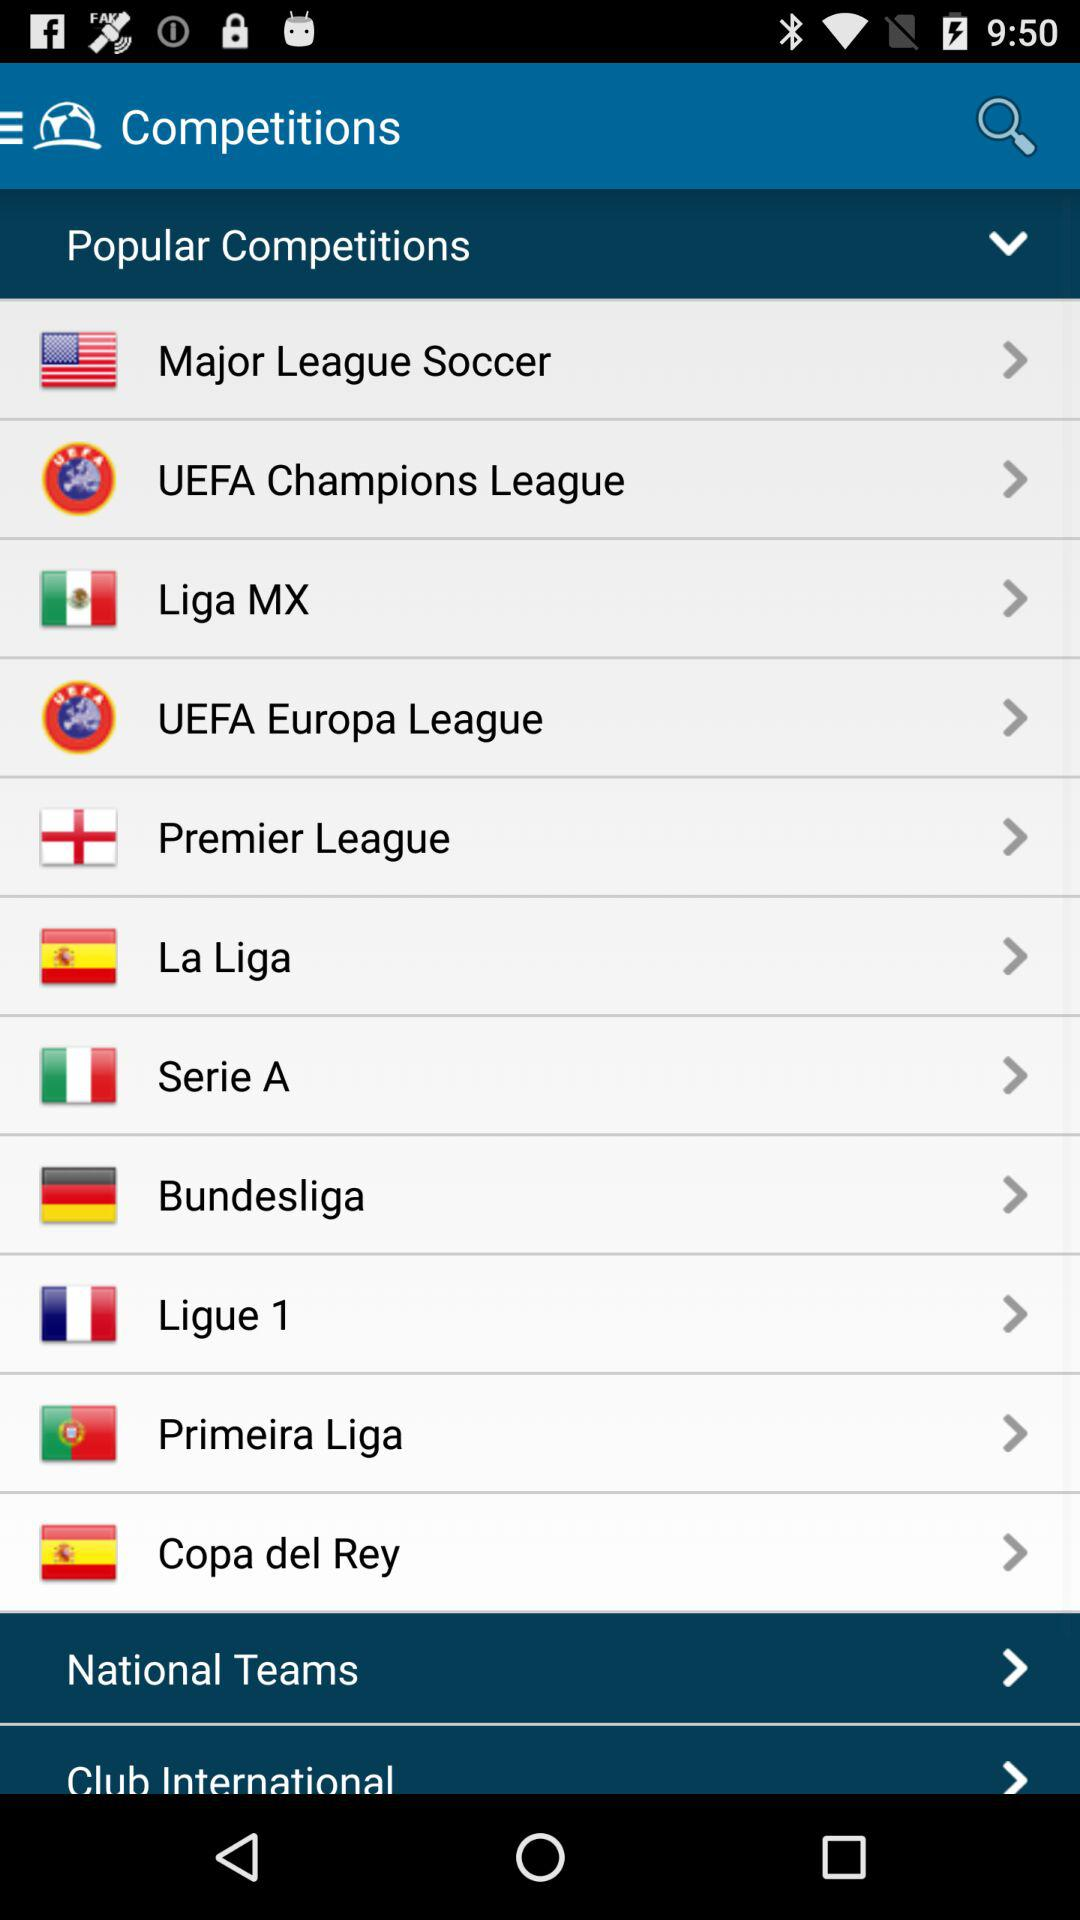What are the names of the popular competitions? The names of the popular competitions are "Major League Soccer", "UEFA Champions League", "Liga MX", "UEFA Europa League", "Premier League", "La Liga", "Serie A", "Bundesliga", "Ligue 1", "Primeira Liga" and "Copa del Rey". 